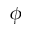<formula> <loc_0><loc_0><loc_500><loc_500>\phi</formula> 